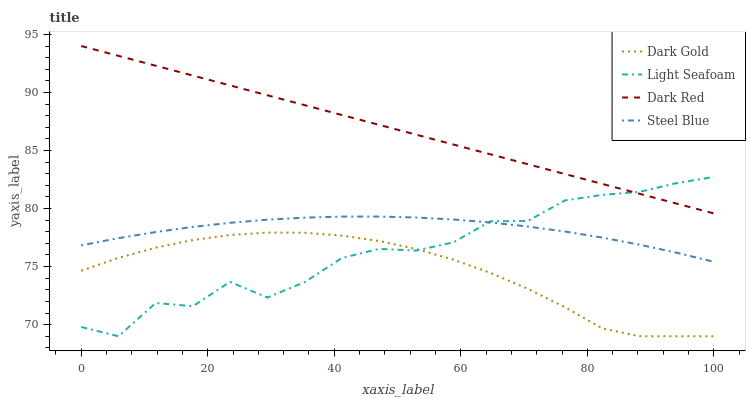Does Dark Gold have the minimum area under the curve?
Answer yes or no. Yes. Does Dark Red have the maximum area under the curve?
Answer yes or no. Yes. Does Light Seafoam have the minimum area under the curve?
Answer yes or no. No. Does Light Seafoam have the maximum area under the curve?
Answer yes or no. No. Is Dark Red the smoothest?
Answer yes or no. Yes. Is Light Seafoam the roughest?
Answer yes or no. Yes. Is Steel Blue the smoothest?
Answer yes or no. No. Is Steel Blue the roughest?
Answer yes or no. No. Does Steel Blue have the lowest value?
Answer yes or no. No. Does Dark Red have the highest value?
Answer yes or no. Yes. Does Light Seafoam have the highest value?
Answer yes or no. No. Is Dark Gold less than Dark Red?
Answer yes or no. Yes. Is Steel Blue greater than Dark Gold?
Answer yes or no. Yes. Does Dark Gold intersect Light Seafoam?
Answer yes or no. Yes. Is Dark Gold less than Light Seafoam?
Answer yes or no. No. Is Dark Gold greater than Light Seafoam?
Answer yes or no. No. Does Dark Gold intersect Dark Red?
Answer yes or no. No. 